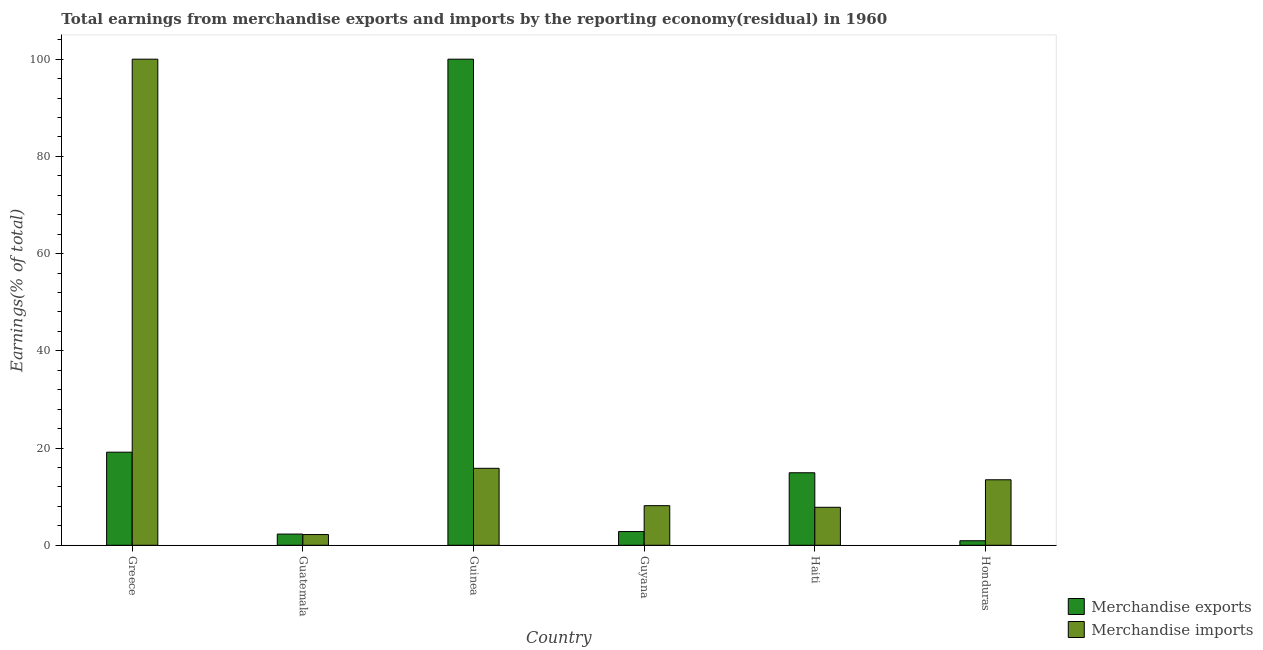How many different coloured bars are there?
Ensure brevity in your answer.  2. Are the number of bars on each tick of the X-axis equal?
Make the answer very short. Yes. How many bars are there on the 1st tick from the left?
Provide a short and direct response. 2. What is the label of the 2nd group of bars from the left?
Make the answer very short. Guatemala. What is the earnings from merchandise imports in Honduras?
Provide a short and direct response. 13.48. Across all countries, what is the minimum earnings from merchandise exports?
Offer a terse response. 0.93. In which country was the earnings from merchandise exports maximum?
Offer a terse response. Guinea. In which country was the earnings from merchandise exports minimum?
Your answer should be compact. Honduras. What is the total earnings from merchandise exports in the graph?
Offer a very short reply. 140.13. What is the difference between the earnings from merchandise exports in Guinea and that in Haiti?
Keep it short and to the point. 85.08. What is the difference between the earnings from merchandise imports in Guyana and the earnings from merchandise exports in Guinea?
Keep it short and to the point. -91.85. What is the average earnings from merchandise imports per country?
Your response must be concise. 24.58. What is the difference between the earnings from merchandise exports and earnings from merchandise imports in Honduras?
Ensure brevity in your answer.  -12.54. In how many countries, is the earnings from merchandise imports greater than 24 %?
Your answer should be very brief. 1. What is the ratio of the earnings from merchandise imports in Guatemala to that in Guinea?
Your answer should be compact. 0.14. What is the difference between the highest and the second highest earnings from merchandise exports?
Your answer should be very brief. 80.85. What is the difference between the highest and the lowest earnings from merchandise exports?
Your response must be concise. 99.07. What does the 1st bar from the right in Honduras represents?
Your answer should be very brief. Merchandise imports. Are all the bars in the graph horizontal?
Provide a succinct answer. No. Does the graph contain any zero values?
Ensure brevity in your answer.  No. How are the legend labels stacked?
Make the answer very short. Vertical. What is the title of the graph?
Your response must be concise. Total earnings from merchandise exports and imports by the reporting economy(residual) in 1960. Does "Under five" appear as one of the legend labels in the graph?
Offer a terse response. No. What is the label or title of the X-axis?
Your answer should be compact. Country. What is the label or title of the Y-axis?
Offer a terse response. Earnings(% of total). What is the Earnings(% of total) of Merchandise exports in Greece?
Provide a succinct answer. 19.15. What is the Earnings(% of total) of Merchandise exports in Guatemala?
Give a very brief answer. 2.3. What is the Earnings(% of total) in Merchandise imports in Guatemala?
Your response must be concise. 2.21. What is the Earnings(% of total) in Merchandise imports in Guinea?
Keep it short and to the point. 15.84. What is the Earnings(% of total) in Merchandise exports in Guyana?
Offer a terse response. 2.83. What is the Earnings(% of total) in Merchandise imports in Guyana?
Your answer should be compact. 8.15. What is the Earnings(% of total) in Merchandise exports in Haiti?
Offer a terse response. 14.92. What is the Earnings(% of total) in Merchandise imports in Haiti?
Provide a succinct answer. 7.82. What is the Earnings(% of total) of Merchandise exports in Honduras?
Offer a terse response. 0.93. What is the Earnings(% of total) of Merchandise imports in Honduras?
Provide a succinct answer. 13.48. Across all countries, what is the maximum Earnings(% of total) in Merchandise exports?
Your answer should be very brief. 100. Across all countries, what is the minimum Earnings(% of total) of Merchandise exports?
Provide a short and direct response. 0.93. Across all countries, what is the minimum Earnings(% of total) of Merchandise imports?
Offer a terse response. 2.21. What is the total Earnings(% of total) of Merchandise exports in the graph?
Provide a succinct answer. 140.13. What is the total Earnings(% of total) in Merchandise imports in the graph?
Your response must be concise. 147.48. What is the difference between the Earnings(% of total) of Merchandise exports in Greece and that in Guatemala?
Offer a terse response. 16.85. What is the difference between the Earnings(% of total) of Merchandise imports in Greece and that in Guatemala?
Make the answer very short. 97.79. What is the difference between the Earnings(% of total) of Merchandise exports in Greece and that in Guinea?
Offer a very short reply. -80.85. What is the difference between the Earnings(% of total) in Merchandise imports in Greece and that in Guinea?
Give a very brief answer. 84.16. What is the difference between the Earnings(% of total) of Merchandise exports in Greece and that in Guyana?
Ensure brevity in your answer.  16.33. What is the difference between the Earnings(% of total) of Merchandise imports in Greece and that in Guyana?
Keep it short and to the point. 91.85. What is the difference between the Earnings(% of total) in Merchandise exports in Greece and that in Haiti?
Offer a terse response. 4.24. What is the difference between the Earnings(% of total) of Merchandise imports in Greece and that in Haiti?
Provide a succinct answer. 92.18. What is the difference between the Earnings(% of total) of Merchandise exports in Greece and that in Honduras?
Your answer should be very brief. 18.22. What is the difference between the Earnings(% of total) of Merchandise imports in Greece and that in Honduras?
Keep it short and to the point. 86.52. What is the difference between the Earnings(% of total) of Merchandise exports in Guatemala and that in Guinea?
Offer a very short reply. -97.69. What is the difference between the Earnings(% of total) in Merchandise imports in Guatemala and that in Guinea?
Your response must be concise. -13.63. What is the difference between the Earnings(% of total) in Merchandise exports in Guatemala and that in Guyana?
Provide a short and direct response. -0.52. What is the difference between the Earnings(% of total) in Merchandise imports in Guatemala and that in Guyana?
Offer a very short reply. -5.94. What is the difference between the Earnings(% of total) in Merchandise exports in Guatemala and that in Haiti?
Make the answer very short. -12.61. What is the difference between the Earnings(% of total) in Merchandise imports in Guatemala and that in Haiti?
Offer a terse response. -5.61. What is the difference between the Earnings(% of total) in Merchandise exports in Guatemala and that in Honduras?
Make the answer very short. 1.37. What is the difference between the Earnings(% of total) in Merchandise imports in Guatemala and that in Honduras?
Keep it short and to the point. -11.27. What is the difference between the Earnings(% of total) of Merchandise exports in Guinea and that in Guyana?
Offer a very short reply. 97.17. What is the difference between the Earnings(% of total) in Merchandise imports in Guinea and that in Guyana?
Your answer should be compact. 7.69. What is the difference between the Earnings(% of total) of Merchandise exports in Guinea and that in Haiti?
Offer a very short reply. 85.08. What is the difference between the Earnings(% of total) of Merchandise imports in Guinea and that in Haiti?
Ensure brevity in your answer.  8.02. What is the difference between the Earnings(% of total) of Merchandise exports in Guinea and that in Honduras?
Offer a terse response. 99.07. What is the difference between the Earnings(% of total) of Merchandise imports in Guinea and that in Honduras?
Offer a terse response. 2.36. What is the difference between the Earnings(% of total) of Merchandise exports in Guyana and that in Haiti?
Make the answer very short. -12.09. What is the difference between the Earnings(% of total) of Merchandise imports in Guyana and that in Haiti?
Ensure brevity in your answer.  0.33. What is the difference between the Earnings(% of total) in Merchandise exports in Guyana and that in Honduras?
Keep it short and to the point. 1.89. What is the difference between the Earnings(% of total) in Merchandise imports in Guyana and that in Honduras?
Your answer should be very brief. -5.33. What is the difference between the Earnings(% of total) of Merchandise exports in Haiti and that in Honduras?
Offer a very short reply. 13.98. What is the difference between the Earnings(% of total) in Merchandise imports in Haiti and that in Honduras?
Ensure brevity in your answer.  -5.66. What is the difference between the Earnings(% of total) of Merchandise exports in Greece and the Earnings(% of total) of Merchandise imports in Guatemala?
Provide a succinct answer. 16.95. What is the difference between the Earnings(% of total) in Merchandise exports in Greece and the Earnings(% of total) in Merchandise imports in Guinea?
Provide a succinct answer. 3.32. What is the difference between the Earnings(% of total) in Merchandise exports in Greece and the Earnings(% of total) in Merchandise imports in Guyana?
Keep it short and to the point. 11. What is the difference between the Earnings(% of total) in Merchandise exports in Greece and the Earnings(% of total) in Merchandise imports in Haiti?
Offer a terse response. 11.34. What is the difference between the Earnings(% of total) in Merchandise exports in Greece and the Earnings(% of total) in Merchandise imports in Honduras?
Your response must be concise. 5.68. What is the difference between the Earnings(% of total) in Merchandise exports in Guatemala and the Earnings(% of total) in Merchandise imports in Guinea?
Offer a very short reply. -13.53. What is the difference between the Earnings(% of total) of Merchandise exports in Guatemala and the Earnings(% of total) of Merchandise imports in Guyana?
Offer a very short reply. -5.84. What is the difference between the Earnings(% of total) of Merchandise exports in Guatemala and the Earnings(% of total) of Merchandise imports in Haiti?
Give a very brief answer. -5.51. What is the difference between the Earnings(% of total) in Merchandise exports in Guatemala and the Earnings(% of total) in Merchandise imports in Honduras?
Offer a terse response. -11.17. What is the difference between the Earnings(% of total) in Merchandise exports in Guinea and the Earnings(% of total) in Merchandise imports in Guyana?
Provide a short and direct response. 91.85. What is the difference between the Earnings(% of total) in Merchandise exports in Guinea and the Earnings(% of total) in Merchandise imports in Haiti?
Give a very brief answer. 92.18. What is the difference between the Earnings(% of total) in Merchandise exports in Guinea and the Earnings(% of total) in Merchandise imports in Honduras?
Offer a terse response. 86.52. What is the difference between the Earnings(% of total) of Merchandise exports in Guyana and the Earnings(% of total) of Merchandise imports in Haiti?
Make the answer very short. -4.99. What is the difference between the Earnings(% of total) of Merchandise exports in Guyana and the Earnings(% of total) of Merchandise imports in Honduras?
Keep it short and to the point. -10.65. What is the difference between the Earnings(% of total) of Merchandise exports in Haiti and the Earnings(% of total) of Merchandise imports in Honduras?
Provide a short and direct response. 1.44. What is the average Earnings(% of total) of Merchandise exports per country?
Give a very brief answer. 23.36. What is the average Earnings(% of total) in Merchandise imports per country?
Ensure brevity in your answer.  24.58. What is the difference between the Earnings(% of total) of Merchandise exports and Earnings(% of total) of Merchandise imports in Greece?
Keep it short and to the point. -80.85. What is the difference between the Earnings(% of total) of Merchandise exports and Earnings(% of total) of Merchandise imports in Guatemala?
Offer a terse response. 0.1. What is the difference between the Earnings(% of total) of Merchandise exports and Earnings(% of total) of Merchandise imports in Guinea?
Offer a terse response. 84.16. What is the difference between the Earnings(% of total) in Merchandise exports and Earnings(% of total) in Merchandise imports in Guyana?
Give a very brief answer. -5.32. What is the difference between the Earnings(% of total) in Merchandise exports and Earnings(% of total) in Merchandise imports in Haiti?
Provide a succinct answer. 7.1. What is the difference between the Earnings(% of total) in Merchandise exports and Earnings(% of total) in Merchandise imports in Honduras?
Make the answer very short. -12.54. What is the ratio of the Earnings(% of total) of Merchandise exports in Greece to that in Guatemala?
Offer a very short reply. 8.31. What is the ratio of the Earnings(% of total) in Merchandise imports in Greece to that in Guatemala?
Make the answer very short. 45.32. What is the ratio of the Earnings(% of total) in Merchandise exports in Greece to that in Guinea?
Give a very brief answer. 0.19. What is the ratio of the Earnings(% of total) of Merchandise imports in Greece to that in Guinea?
Your answer should be very brief. 6.31. What is the ratio of the Earnings(% of total) in Merchandise exports in Greece to that in Guyana?
Your answer should be compact. 6.78. What is the ratio of the Earnings(% of total) in Merchandise imports in Greece to that in Guyana?
Provide a short and direct response. 12.27. What is the ratio of the Earnings(% of total) of Merchandise exports in Greece to that in Haiti?
Give a very brief answer. 1.28. What is the ratio of the Earnings(% of total) in Merchandise imports in Greece to that in Haiti?
Ensure brevity in your answer.  12.79. What is the ratio of the Earnings(% of total) in Merchandise exports in Greece to that in Honduras?
Your answer should be compact. 20.53. What is the ratio of the Earnings(% of total) of Merchandise imports in Greece to that in Honduras?
Provide a succinct answer. 7.42. What is the ratio of the Earnings(% of total) of Merchandise exports in Guatemala to that in Guinea?
Keep it short and to the point. 0.02. What is the ratio of the Earnings(% of total) in Merchandise imports in Guatemala to that in Guinea?
Your response must be concise. 0.14. What is the ratio of the Earnings(% of total) in Merchandise exports in Guatemala to that in Guyana?
Keep it short and to the point. 0.82. What is the ratio of the Earnings(% of total) of Merchandise imports in Guatemala to that in Guyana?
Give a very brief answer. 0.27. What is the ratio of the Earnings(% of total) in Merchandise exports in Guatemala to that in Haiti?
Keep it short and to the point. 0.15. What is the ratio of the Earnings(% of total) of Merchandise imports in Guatemala to that in Haiti?
Offer a very short reply. 0.28. What is the ratio of the Earnings(% of total) in Merchandise exports in Guatemala to that in Honduras?
Ensure brevity in your answer.  2.47. What is the ratio of the Earnings(% of total) in Merchandise imports in Guatemala to that in Honduras?
Your response must be concise. 0.16. What is the ratio of the Earnings(% of total) of Merchandise exports in Guinea to that in Guyana?
Your answer should be compact. 35.38. What is the ratio of the Earnings(% of total) in Merchandise imports in Guinea to that in Guyana?
Your answer should be very brief. 1.94. What is the ratio of the Earnings(% of total) in Merchandise exports in Guinea to that in Haiti?
Provide a short and direct response. 6.7. What is the ratio of the Earnings(% of total) of Merchandise imports in Guinea to that in Haiti?
Provide a short and direct response. 2.03. What is the ratio of the Earnings(% of total) in Merchandise exports in Guinea to that in Honduras?
Your answer should be very brief. 107.17. What is the ratio of the Earnings(% of total) in Merchandise imports in Guinea to that in Honduras?
Your answer should be compact. 1.18. What is the ratio of the Earnings(% of total) of Merchandise exports in Guyana to that in Haiti?
Give a very brief answer. 0.19. What is the ratio of the Earnings(% of total) of Merchandise imports in Guyana to that in Haiti?
Offer a terse response. 1.04. What is the ratio of the Earnings(% of total) in Merchandise exports in Guyana to that in Honduras?
Ensure brevity in your answer.  3.03. What is the ratio of the Earnings(% of total) in Merchandise imports in Guyana to that in Honduras?
Provide a short and direct response. 0.6. What is the ratio of the Earnings(% of total) of Merchandise exports in Haiti to that in Honduras?
Ensure brevity in your answer.  15.99. What is the ratio of the Earnings(% of total) in Merchandise imports in Haiti to that in Honduras?
Make the answer very short. 0.58. What is the difference between the highest and the second highest Earnings(% of total) in Merchandise exports?
Offer a very short reply. 80.85. What is the difference between the highest and the second highest Earnings(% of total) of Merchandise imports?
Offer a very short reply. 84.16. What is the difference between the highest and the lowest Earnings(% of total) of Merchandise exports?
Your answer should be very brief. 99.07. What is the difference between the highest and the lowest Earnings(% of total) in Merchandise imports?
Offer a very short reply. 97.79. 